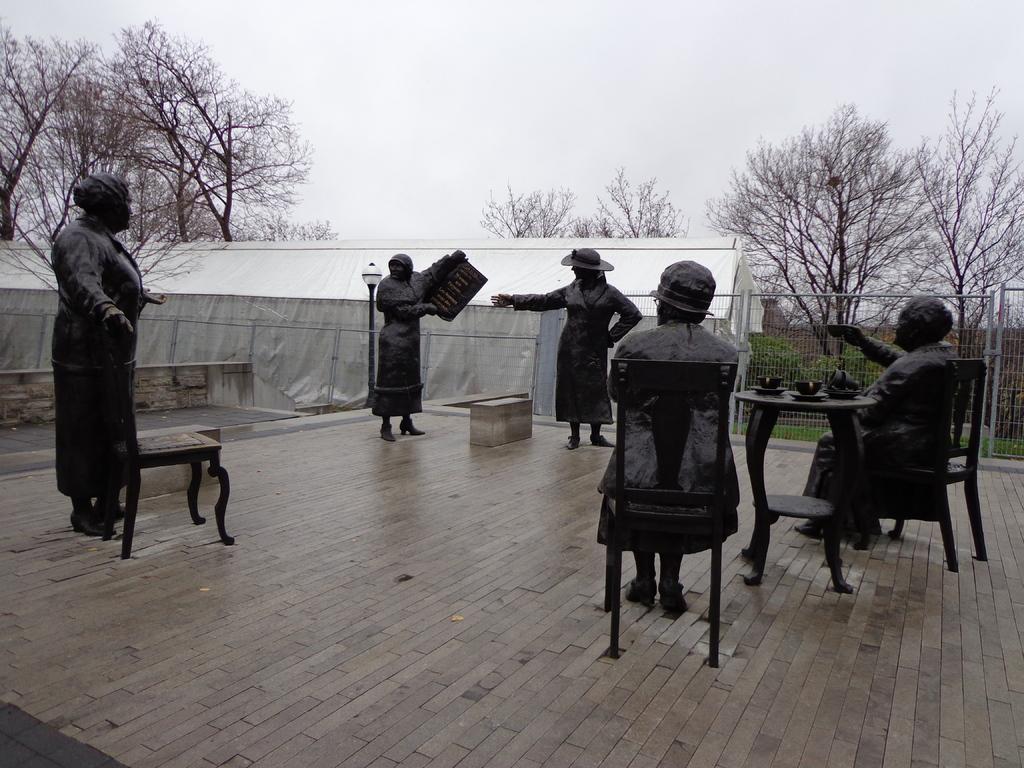Please provide a concise description of this image. In this picture we can see a few statues and a wooden block on the path. A shed is visible on the left side. We can see some fencing from left to right. There are few trees in the background. 